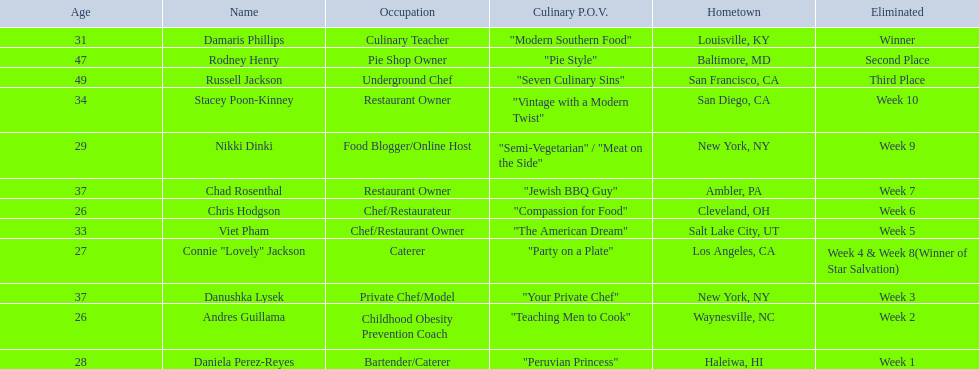Who faced elimination first, nikki dinki or viet pham? Viet Pham. 